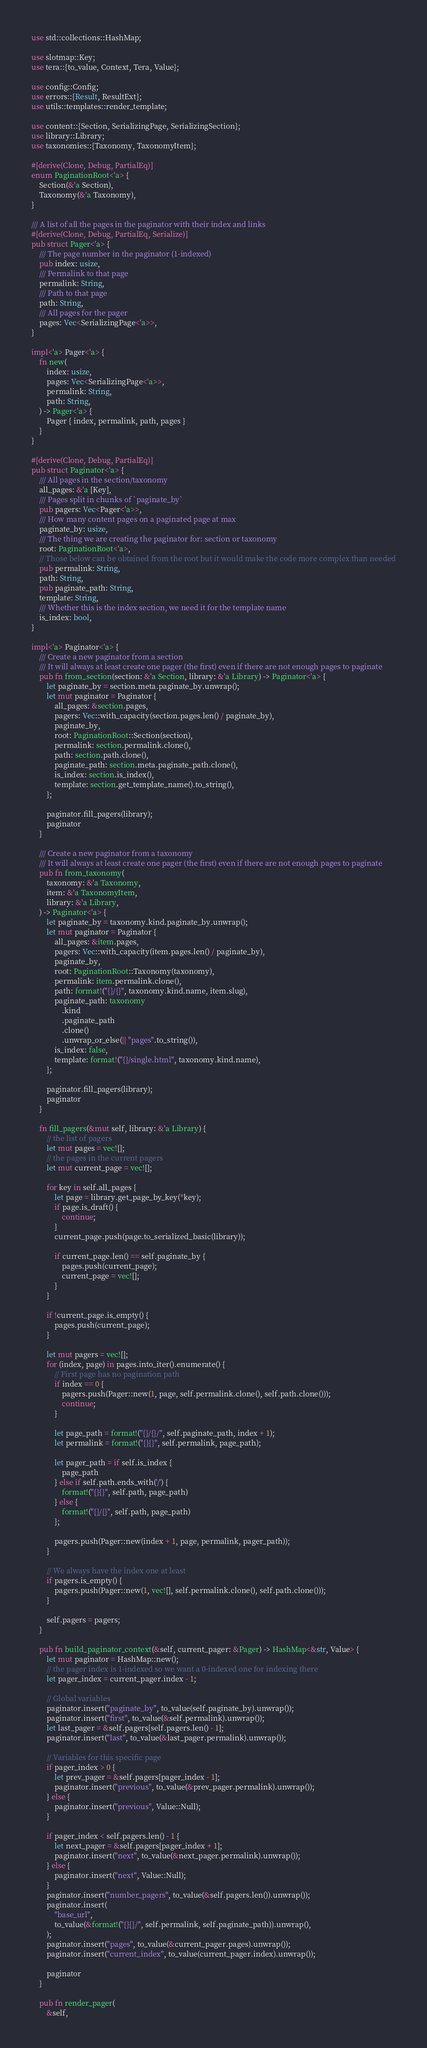<code> <loc_0><loc_0><loc_500><loc_500><_Rust_>use std::collections::HashMap;

use slotmap::Key;
use tera::{to_value, Context, Tera, Value};

use config::Config;
use errors::{Result, ResultExt};
use utils::templates::render_template;

use content::{Section, SerializingPage, SerializingSection};
use library::Library;
use taxonomies::{Taxonomy, TaxonomyItem};

#[derive(Clone, Debug, PartialEq)]
enum PaginationRoot<'a> {
    Section(&'a Section),
    Taxonomy(&'a Taxonomy),
}

/// A list of all the pages in the paginator with their index and links
#[derive(Clone, Debug, PartialEq, Serialize)]
pub struct Pager<'a> {
    /// The page number in the paginator (1-indexed)
    pub index: usize,
    /// Permalink to that page
    permalink: String,
    /// Path to that page
    path: String,
    /// All pages for the pager
    pages: Vec<SerializingPage<'a>>,
}

impl<'a> Pager<'a> {
    fn new(
        index: usize,
        pages: Vec<SerializingPage<'a>>,
        permalink: String,
        path: String,
    ) -> Pager<'a> {
        Pager { index, permalink, path, pages }
    }
}

#[derive(Clone, Debug, PartialEq)]
pub struct Paginator<'a> {
    /// All pages in the section/taxonomy
    all_pages: &'a [Key],
    /// Pages split in chunks of `paginate_by`
    pub pagers: Vec<Pager<'a>>,
    /// How many content pages on a paginated page at max
    paginate_by: usize,
    /// The thing we are creating the paginator for: section or taxonomy
    root: PaginationRoot<'a>,
    // Those below can be obtained from the root but it would make the code more complex than needed
    pub permalink: String,
    path: String,
    pub paginate_path: String,
    template: String,
    /// Whether this is the index section, we need it for the template name
    is_index: bool,
}

impl<'a> Paginator<'a> {
    /// Create a new paginator from a section
    /// It will always at least create one pager (the first) even if there are not enough pages to paginate
    pub fn from_section(section: &'a Section, library: &'a Library) -> Paginator<'a> {
        let paginate_by = section.meta.paginate_by.unwrap();
        let mut paginator = Paginator {
            all_pages: &section.pages,
            pagers: Vec::with_capacity(section.pages.len() / paginate_by),
            paginate_by,
            root: PaginationRoot::Section(section),
            permalink: section.permalink.clone(),
            path: section.path.clone(),
            paginate_path: section.meta.paginate_path.clone(),
            is_index: section.is_index(),
            template: section.get_template_name().to_string(),
        };

        paginator.fill_pagers(library);
        paginator
    }

    /// Create a new paginator from a taxonomy
    /// It will always at least create one pager (the first) even if there are not enough pages to paginate
    pub fn from_taxonomy(
        taxonomy: &'a Taxonomy,
        item: &'a TaxonomyItem,
        library: &'a Library,
    ) -> Paginator<'a> {
        let paginate_by = taxonomy.kind.paginate_by.unwrap();
        let mut paginator = Paginator {
            all_pages: &item.pages,
            pagers: Vec::with_capacity(item.pages.len() / paginate_by),
            paginate_by,
            root: PaginationRoot::Taxonomy(taxonomy),
            permalink: item.permalink.clone(),
            path: format!("{}/{}", taxonomy.kind.name, item.slug),
            paginate_path: taxonomy
                .kind
                .paginate_path
                .clone()
                .unwrap_or_else(|| "pages".to_string()),
            is_index: false,
            template: format!("{}/single.html", taxonomy.kind.name),
        };

        paginator.fill_pagers(library);
        paginator
    }

    fn fill_pagers(&mut self, library: &'a Library) {
        // the list of pagers
        let mut pages = vec![];
        // the pages in the current pagers
        let mut current_page = vec![];

        for key in self.all_pages {
            let page = library.get_page_by_key(*key);
            if page.is_draft() {
                continue;
            }
            current_page.push(page.to_serialized_basic(library));

            if current_page.len() == self.paginate_by {
                pages.push(current_page);
                current_page = vec![];
            }
        }

        if !current_page.is_empty() {
            pages.push(current_page);
        }

        let mut pagers = vec![];
        for (index, page) in pages.into_iter().enumerate() {
            // First page has no pagination path
            if index == 0 {
                pagers.push(Pager::new(1, page, self.permalink.clone(), self.path.clone()));
                continue;
            }

            let page_path = format!("{}/{}/", self.paginate_path, index + 1);
            let permalink = format!("{}{}", self.permalink, page_path);

            let pager_path = if self.is_index {
                page_path
            } else if self.path.ends_with('/') {
                format!("{}{}", self.path, page_path)
            } else {
                format!("{}/{}", self.path, page_path)
            };

            pagers.push(Pager::new(index + 1, page, permalink, pager_path));
        }

        // We always have the index one at least
        if pagers.is_empty() {
            pagers.push(Pager::new(1, vec![], self.permalink.clone(), self.path.clone()));
        }

        self.pagers = pagers;
    }

    pub fn build_paginator_context(&self, current_pager: &Pager) -> HashMap<&str, Value> {
        let mut paginator = HashMap::new();
        // the pager index is 1-indexed so we want a 0-indexed one for indexing there
        let pager_index = current_pager.index - 1;

        // Global variables
        paginator.insert("paginate_by", to_value(self.paginate_by).unwrap());
        paginator.insert("first", to_value(&self.permalink).unwrap());
        let last_pager = &self.pagers[self.pagers.len() - 1];
        paginator.insert("last", to_value(&last_pager.permalink).unwrap());

        // Variables for this specific page
        if pager_index > 0 {
            let prev_pager = &self.pagers[pager_index - 1];
            paginator.insert("previous", to_value(&prev_pager.permalink).unwrap());
        } else {
            paginator.insert("previous", Value::Null);
        }

        if pager_index < self.pagers.len() - 1 {
            let next_pager = &self.pagers[pager_index + 1];
            paginator.insert("next", to_value(&next_pager.permalink).unwrap());
        } else {
            paginator.insert("next", Value::Null);
        }
        paginator.insert("number_pagers", to_value(&self.pagers.len()).unwrap());
        paginator.insert(
            "base_url",
            to_value(&format!("{}{}/", self.permalink, self.paginate_path)).unwrap(),
        );
        paginator.insert("pages", to_value(&current_pager.pages).unwrap());
        paginator.insert("current_index", to_value(current_pager.index).unwrap());

        paginator
    }

    pub fn render_pager(
        &self,</code> 